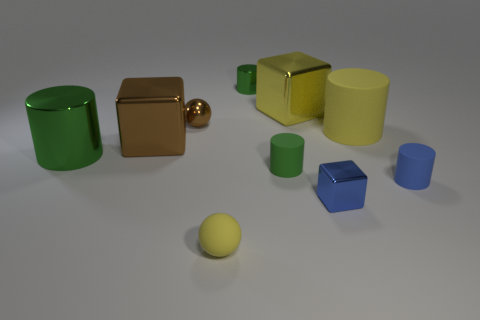Subtract all blue cubes. How many green cylinders are left? 3 Subtract all large shiny blocks. How many blocks are left? 1 Subtract all blue cylinders. How many cylinders are left? 4 Subtract all cubes. How many objects are left? 7 Subtract 2 spheres. How many spheres are left? 0 Subtract all purple objects. Subtract all yellow matte objects. How many objects are left? 8 Add 3 tiny blue metallic cubes. How many tiny blue metallic cubes are left? 4 Add 6 big cyan matte spheres. How many big cyan matte spheres exist? 6 Subtract 0 cyan blocks. How many objects are left? 10 Subtract all brown spheres. Subtract all brown blocks. How many spheres are left? 1 